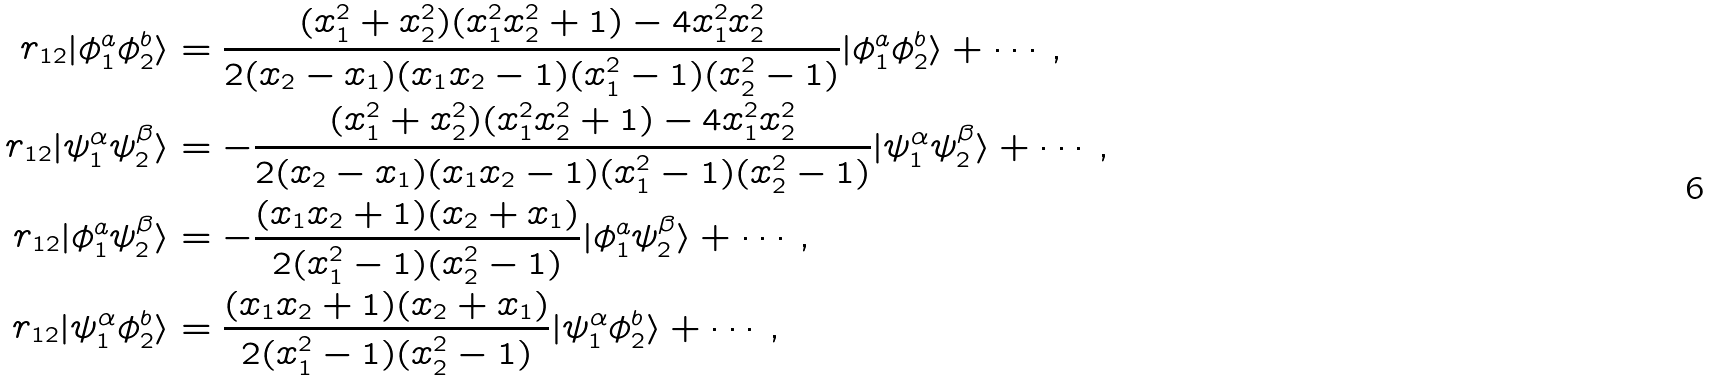Convert formula to latex. <formula><loc_0><loc_0><loc_500><loc_500>r _ { 1 2 } | \phi ^ { a } _ { 1 } \phi ^ { b } _ { 2 } \rangle & = \frac { ( x _ { 1 } ^ { 2 } + x _ { 2 } ^ { 2 } ) ( x _ { 1 } ^ { 2 } x _ { 2 } ^ { 2 } + 1 ) - 4 x _ { 1 } ^ { 2 } x _ { 2 } ^ { 2 } } { 2 ( x _ { 2 } - x _ { 1 } ) ( x _ { 1 } x _ { 2 } - 1 ) ( x _ { 1 } ^ { 2 } - 1 ) ( x _ { 2 } ^ { 2 } - 1 ) } | \phi ^ { a } _ { 1 } \phi ^ { b } _ { 2 } \rangle + \cdots , \\ r _ { 1 2 } | \psi ^ { \alpha } _ { 1 } \psi ^ { \beta } _ { 2 } \rangle & = - \frac { ( x _ { 1 } ^ { 2 } + x _ { 2 } ^ { 2 } ) ( x _ { 1 } ^ { 2 } x _ { 2 } ^ { 2 } + 1 ) - 4 x _ { 1 } ^ { 2 } x _ { 2 } ^ { 2 } } { 2 ( x _ { 2 } - x _ { 1 } ) ( x _ { 1 } x _ { 2 } - 1 ) ( x _ { 1 } ^ { 2 } - 1 ) ( x _ { 2 } ^ { 2 } - 1 ) } | \psi ^ { \alpha } _ { 1 } \psi ^ { \beta } _ { 2 } \rangle + \cdots , \\ r _ { 1 2 } | \phi ^ { a } _ { 1 } \psi ^ { \beta } _ { 2 } \rangle & = - \frac { ( x _ { 1 } x _ { 2 } + 1 ) ( x _ { 2 } + x _ { 1 } ) } { 2 ( x _ { 1 } ^ { 2 } - 1 ) ( x _ { 2 } ^ { 2 } - 1 ) } | \phi ^ { a } _ { 1 } \psi ^ { \beta } _ { 2 } \rangle + \cdots , \\ r _ { 1 2 } | \psi ^ { \alpha } _ { 1 } \phi ^ { b } _ { 2 } \rangle & = \frac { ( x _ { 1 } x _ { 2 } + 1 ) ( x _ { 2 } + x _ { 1 } ) } { 2 ( x _ { 1 } ^ { 2 } - 1 ) ( x _ { 2 } ^ { 2 } - 1 ) } | \psi ^ { \alpha } _ { 1 } \phi ^ { b } _ { 2 } \rangle + \cdots ,</formula> 